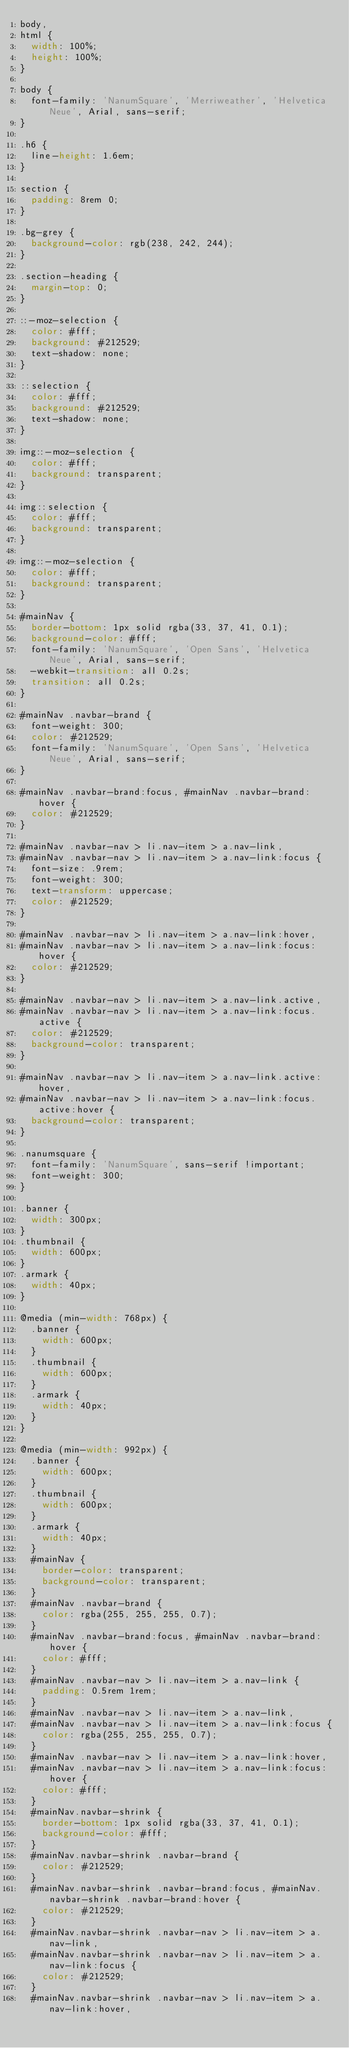<code> <loc_0><loc_0><loc_500><loc_500><_CSS_>body,
html {
  width: 100%;
  height: 100%;
}

body {
  font-family: 'NanumSquare', 'Merriweather', 'Helvetica Neue', Arial, sans-serif;
}

.h6 {
  line-height: 1.6em;
}

section {
  padding: 8rem 0;
}

.bg-grey {
  background-color: rgb(238, 242, 244);
}

.section-heading {
  margin-top: 0;
}

::-moz-selection {
  color: #fff;
  background: #212529;
  text-shadow: none;
}

::selection {
  color: #fff;
  background: #212529;
  text-shadow: none;
}

img::-moz-selection {
  color: #fff;
  background: transparent;
}

img::selection {
  color: #fff;
  background: transparent;
}

img::-moz-selection {
  color: #fff;
  background: transparent;
}

#mainNav {
  border-bottom: 1px solid rgba(33, 37, 41, 0.1);
  background-color: #fff;
  font-family: 'NanumSquare', 'Open Sans', 'Helvetica Neue', Arial, sans-serif;
  -webkit-transition: all 0.2s;
  transition: all 0.2s;
}

#mainNav .navbar-brand {
  font-weight: 300;
  color: #212529;
  font-family: 'NanumSquare', 'Open Sans', 'Helvetica Neue', Arial, sans-serif;
}

#mainNav .navbar-brand:focus, #mainNav .navbar-brand:hover {
  color: #212529;
}

#mainNav .navbar-nav > li.nav-item > a.nav-link,
#mainNav .navbar-nav > li.nav-item > a.nav-link:focus {
  font-size: .9rem;
  font-weight: 300;
  text-transform: uppercase;
  color: #212529;
}

#mainNav .navbar-nav > li.nav-item > a.nav-link:hover,
#mainNav .navbar-nav > li.nav-item > a.nav-link:focus:hover {
  color: #212529;
}

#mainNav .navbar-nav > li.nav-item > a.nav-link.active,
#mainNav .navbar-nav > li.nav-item > a.nav-link:focus.active {
  color: #212529;
  background-color: transparent;
}

#mainNav .navbar-nav > li.nav-item > a.nav-link.active:hover,
#mainNav .navbar-nav > li.nav-item > a.nav-link:focus.active:hover {
  background-color: transparent;
}

.nanumsquare {
  font-family: 'NanumSquare', sans-serif !important;
  font-weight: 300;
}

.banner {
  width: 300px;
}
.thumbnail {
  width: 600px;
}
.armark {
  width: 40px;
}

@media (min-width: 768px) {
  .banner {
    width: 600px;
  }
  .thumbnail {
    width: 600px;
  }
  .armark {
    width: 40px;
  }
}

@media (min-width: 992px) {
  .banner {
    width: 600px;
  }
  .thumbnail {
    width: 600px;
  }
  .armark {
    width: 40px;
  }
  #mainNav {
    border-color: transparent;
    background-color: transparent;
  }
  #mainNav .navbar-brand {
    color: rgba(255, 255, 255, 0.7);
  }
  #mainNav .navbar-brand:focus, #mainNav .navbar-brand:hover {
    color: #fff;
  }
  #mainNav .navbar-nav > li.nav-item > a.nav-link {
    padding: 0.5rem 1rem;
  }
  #mainNav .navbar-nav > li.nav-item > a.nav-link,
  #mainNav .navbar-nav > li.nav-item > a.nav-link:focus {
    color: rgba(255, 255, 255, 0.7);
  }
  #mainNav .navbar-nav > li.nav-item > a.nav-link:hover,
  #mainNav .navbar-nav > li.nav-item > a.nav-link:focus:hover {
    color: #fff;
  }
  #mainNav.navbar-shrink {
    border-bottom: 1px solid rgba(33, 37, 41, 0.1);
    background-color: #fff;
  }
  #mainNav.navbar-shrink .navbar-brand {
    color: #212529;
  }
  #mainNav.navbar-shrink .navbar-brand:focus, #mainNav.navbar-shrink .navbar-brand:hover {
    color: #212529;
  }
  #mainNav.navbar-shrink .navbar-nav > li.nav-item > a.nav-link,
  #mainNav.navbar-shrink .navbar-nav > li.nav-item > a.nav-link:focus {
    color: #212529;
  }
  #mainNav.navbar-shrink .navbar-nav > li.nav-item > a.nav-link:hover,</code> 